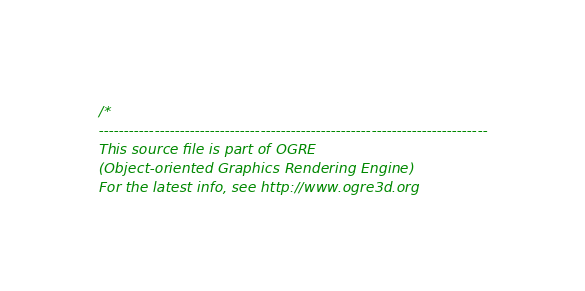Convert code to text. <code><loc_0><loc_0><loc_500><loc_500><_ObjectiveC_>/*
-----------------------------------------------------------------------------
This source file is part of OGRE
(Object-oriented Graphics Rendering Engine)
For the latest info, see http://www.ogre3d.org
</code> 